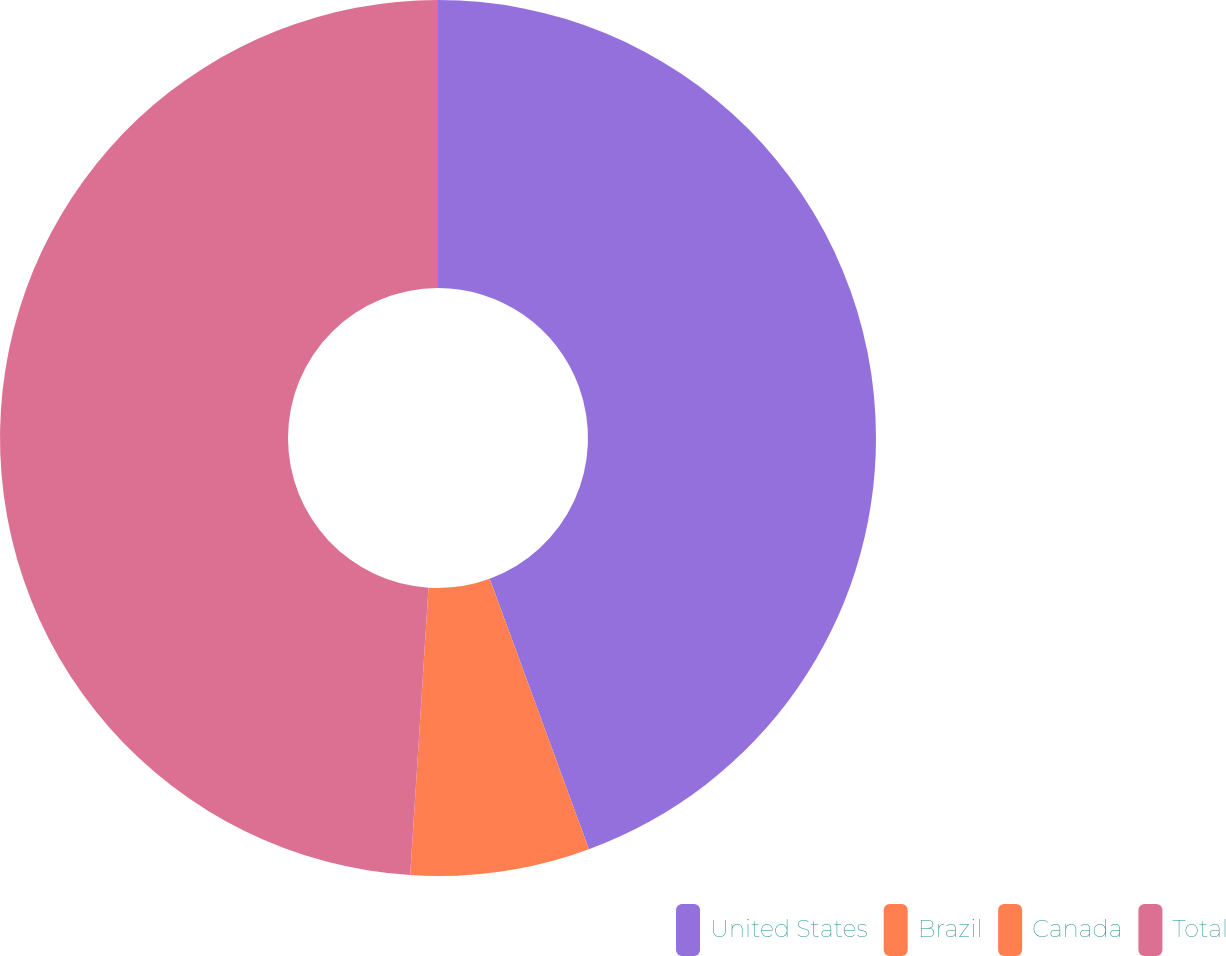<chart> <loc_0><loc_0><loc_500><loc_500><pie_chart><fcel>United States<fcel>Brazil<fcel>Canada<fcel>Total<nl><fcel>44.4%<fcel>5.6%<fcel>1.01%<fcel>48.99%<nl></chart> 